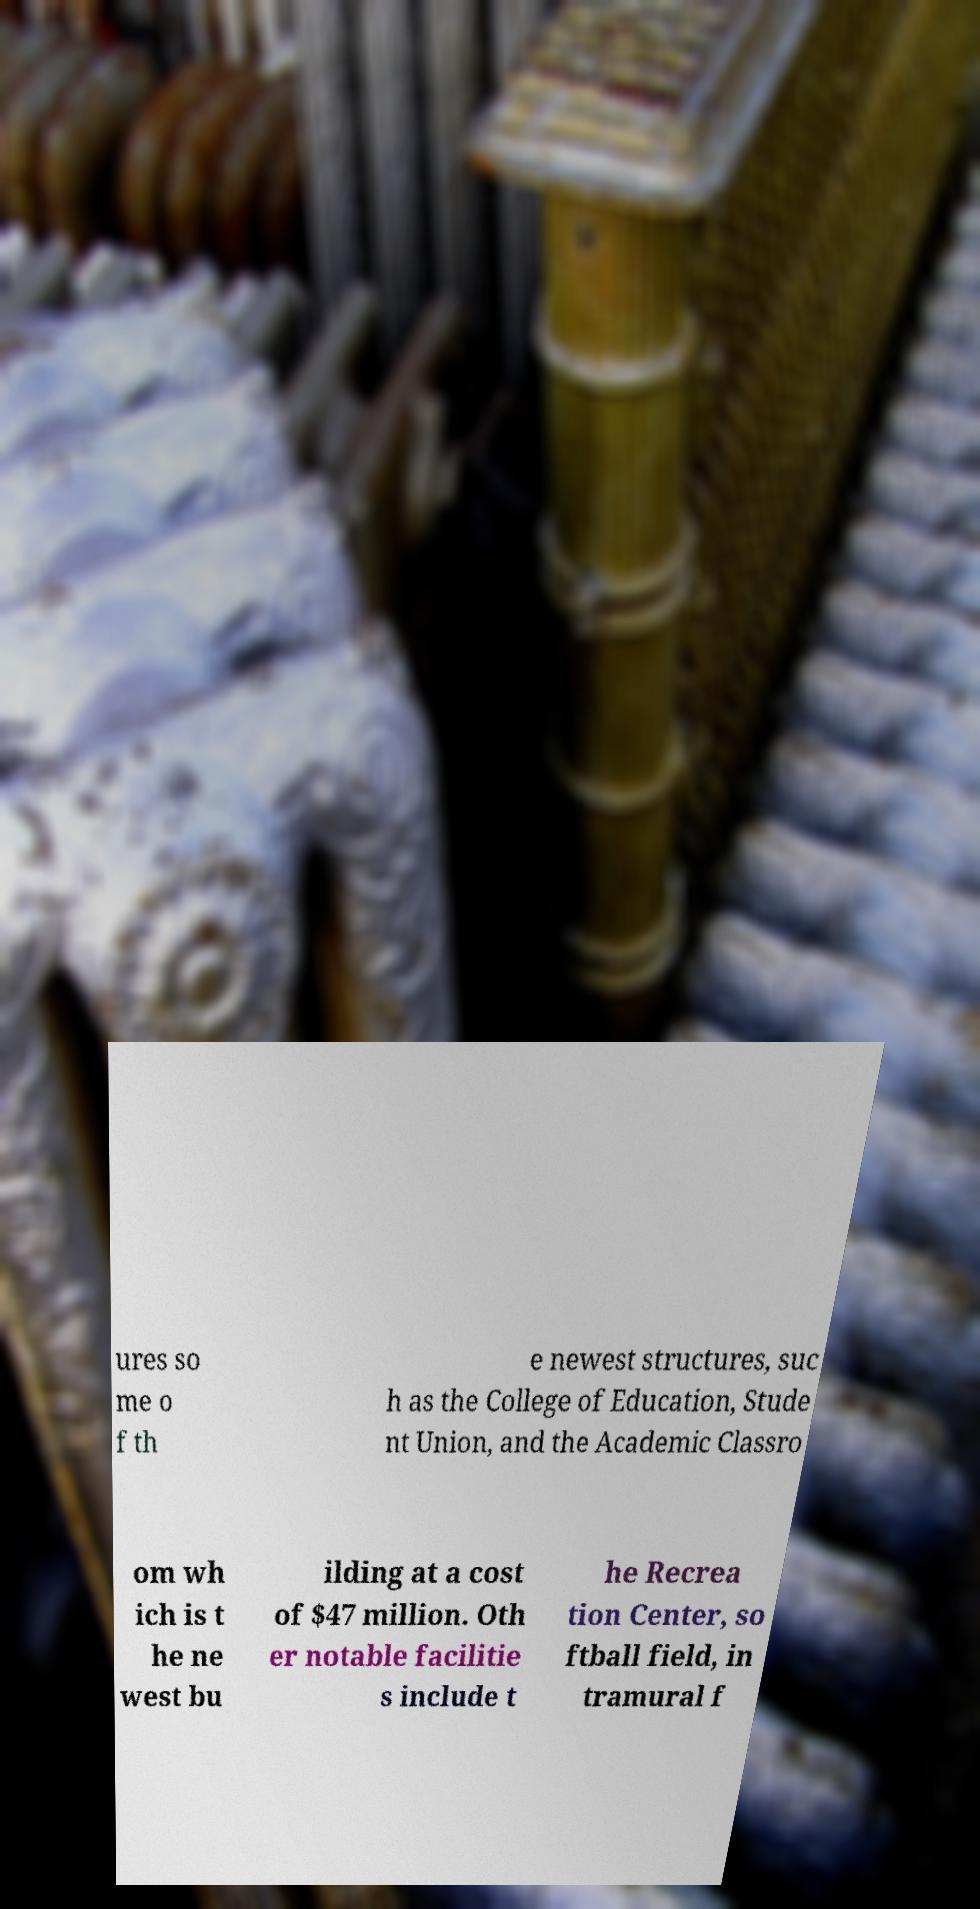Please identify and transcribe the text found in this image. ures so me o f th e newest structures, suc h as the College of Education, Stude nt Union, and the Academic Classro om wh ich is t he ne west bu ilding at a cost of $47 million. Oth er notable facilitie s include t he Recrea tion Center, so ftball field, in tramural f 